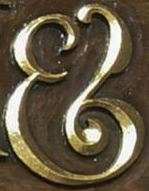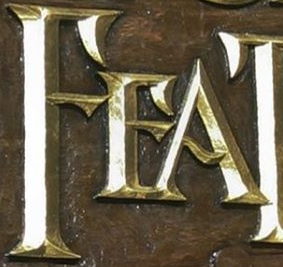What text is displayed in these images sequentially, separated by a semicolon? &; FEA 